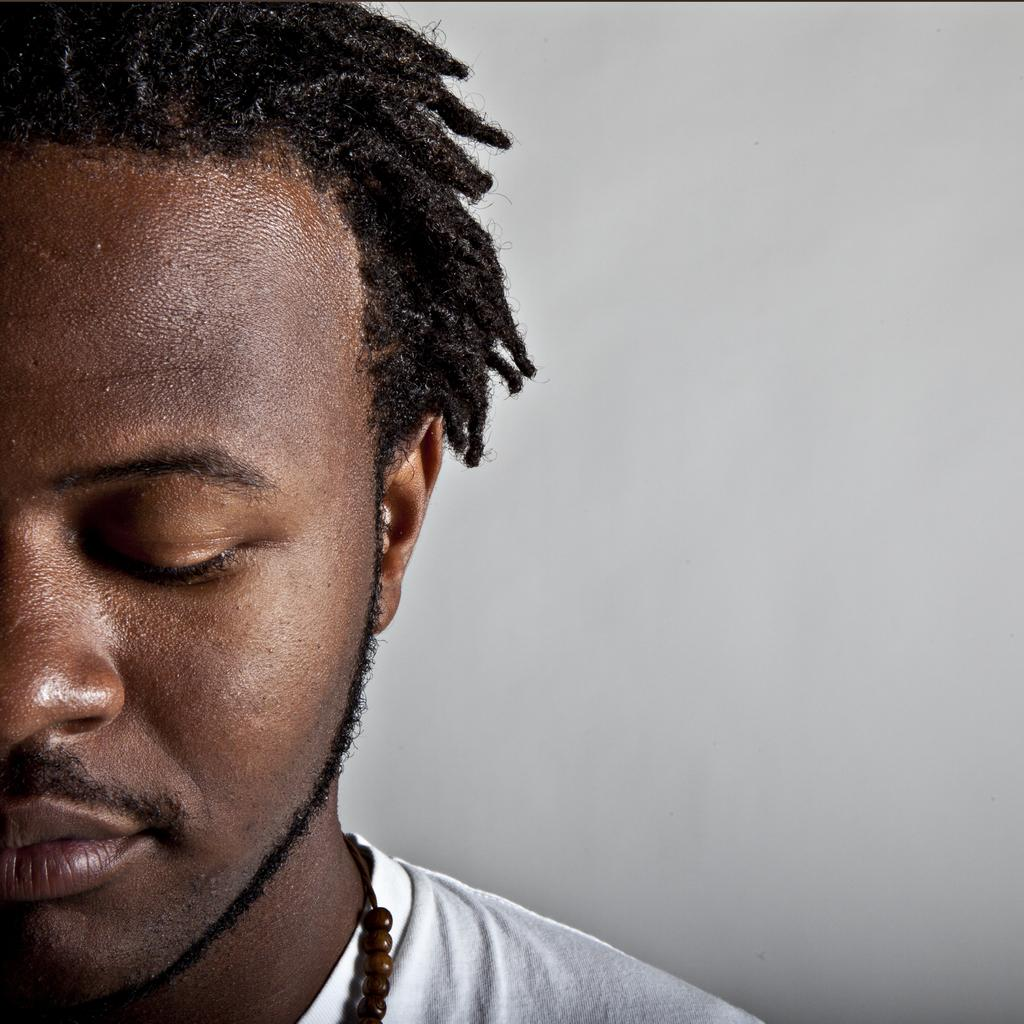Who is present in the image? There is a man in the image. What type of night activity is the man participating in the image? There is no information about a night activity or any activity in the image. The image only shows a man, and we cannot assume any specific activity or context. 